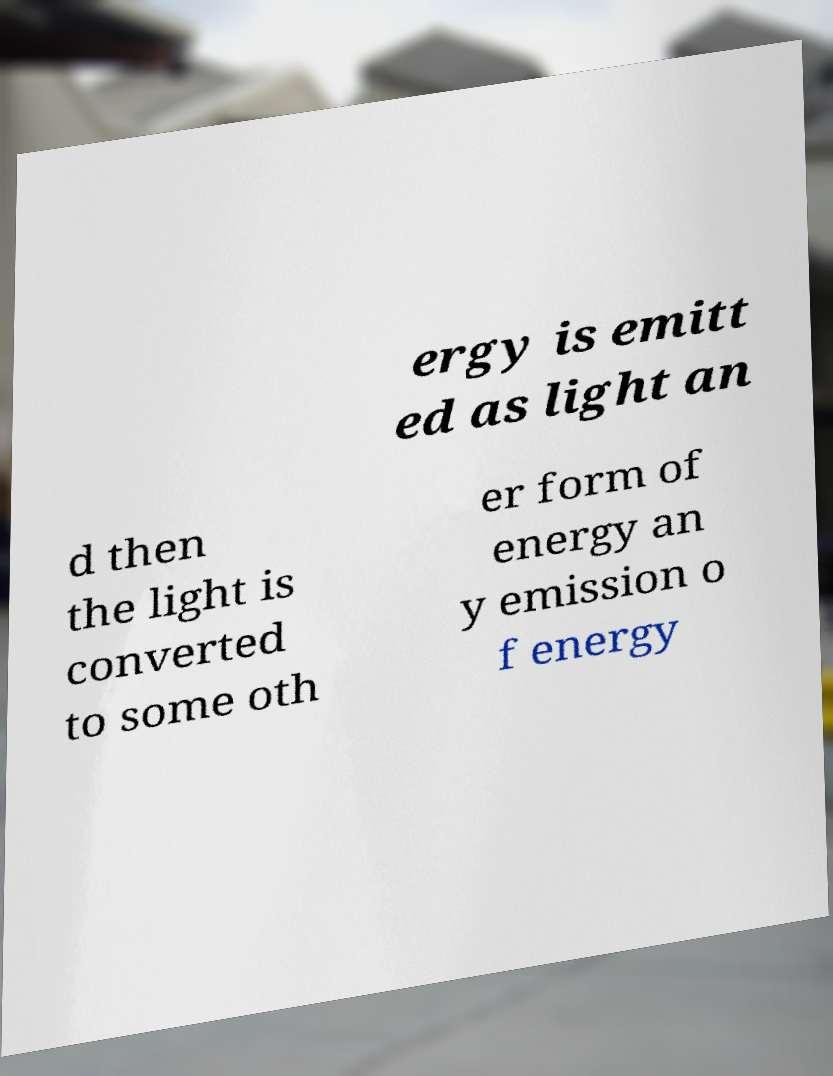Please read and relay the text visible in this image. What does it say? ergy is emitt ed as light an d then the light is converted to some oth er form of energy an y emission o f energy 